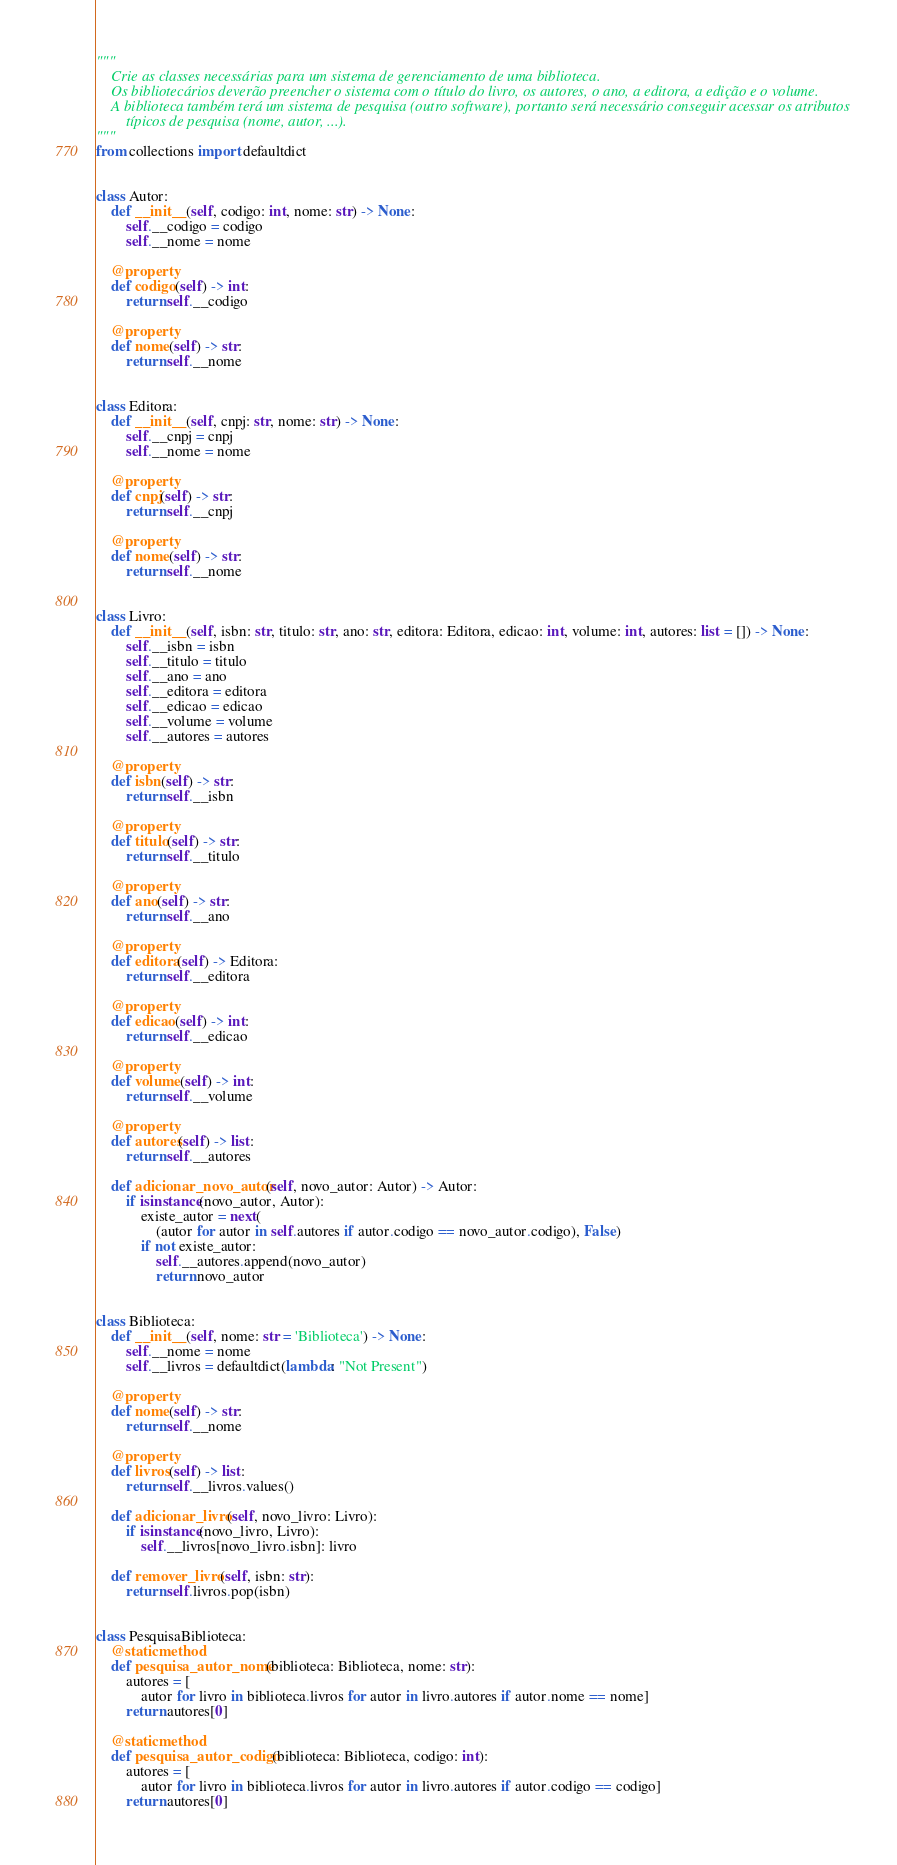Convert code to text. <code><loc_0><loc_0><loc_500><loc_500><_Python_>"""
    Crie as classes necessárias para um sistema de gerenciamento de uma biblioteca. 
    Os bibliotecários deverão preencher o sistema com o título do livro, os autores, o ano, a editora, a edição e o volume.
    A biblioteca também terá um sistema de pesquisa (outro software), portanto será necessário conseguir acessar os atributos
        típicos de pesquisa (nome, autor, ...).
"""
from collections import defaultdict


class Autor:
    def __init__(self, codigo: int, nome: str) -> None:
        self.__codigo = codigo
        self.__nome = nome

    @property
    def codigo(self) -> int:
        return self.__codigo

    @property
    def nome(self) -> str:
        return self.__nome


class Editora:
    def __init__(self, cnpj: str, nome: str) -> None:
        self.__cnpj = cnpj
        self.__nome = nome

    @property
    def cnpj(self) -> str:
        return self.__cnpj

    @property
    def nome(self) -> str:
        return self.__nome


class Livro:
    def __init__(self, isbn: str, titulo: str, ano: str, editora: Editora, edicao: int, volume: int, autores: list = []) -> None:
        self.__isbn = isbn
        self.__titulo = titulo
        self.__ano = ano
        self.__editora = editora
        self.__edicao = edicao
        self.__volume = volume
        self.__autores = autores

    @property
    def isbn(self) -> str:
        return self.__isbn

    @property
    def titulo(self) -> str:
        return self.__titulo

    @property
    def ano(self) -> str:
        return self.__ano

    @property
    def editora(self) -> Editora:
        return self.__editora

    @property
    def edicao(self) -> int:
        return self.__edicao

    @property
    def volume(self) -> int:
        return self.__volume

    @property
    def autores(self) -> list:
        return self.__autores

    def adicionar_novo_autor(self, novo_autor: Autor) -> Autor:
        if isinstance(novo_autor, Autor):
            existe_autor = next(
                (autor for autor in self.autores if autor.codigo == novo_autor.codigo), False)
            if not existe_autor:
                self.__autores.append(novo_autor)
                return novo_autor


class Biblioteca:
    def __init__(self, nome: str = 'Biblioteca') -> None:
        self.__nome = nome
        self.__livros = defaultdict(lambda: "Not Present")

    @property
    def nome(self) -> str:
        return self.__nome

    @property
    def livros(self) -> list:
        return self.__livros.values()

    def adicionar_livro(self, novo_livro: Livro):
        if isinstance(novo_livro, Livro):
            self.__livros[novo_livro.isbn]: livro

    def remover_livro(self, isbn: str):
        return self.livros.pop(isbn)


class PesquisaBiblioteca:
    @staticmethod
    def pesquisa_autor_nome(biblioteca: Biblioteca, nome: str):
        autores = [
            autor for livro in biblioteca.livros for autor in livro.autores if autor.nome == nome]
        return autores[0]

    @staticmethod
    def pesquisa_autor_codigo(biblioteca: Biblioteca, codigo: int):
        autores = [
            autor for livro in biblioteca.livros for autor in livro.autores if autor.codigo == codigo]
        return autores[0]
</code> 